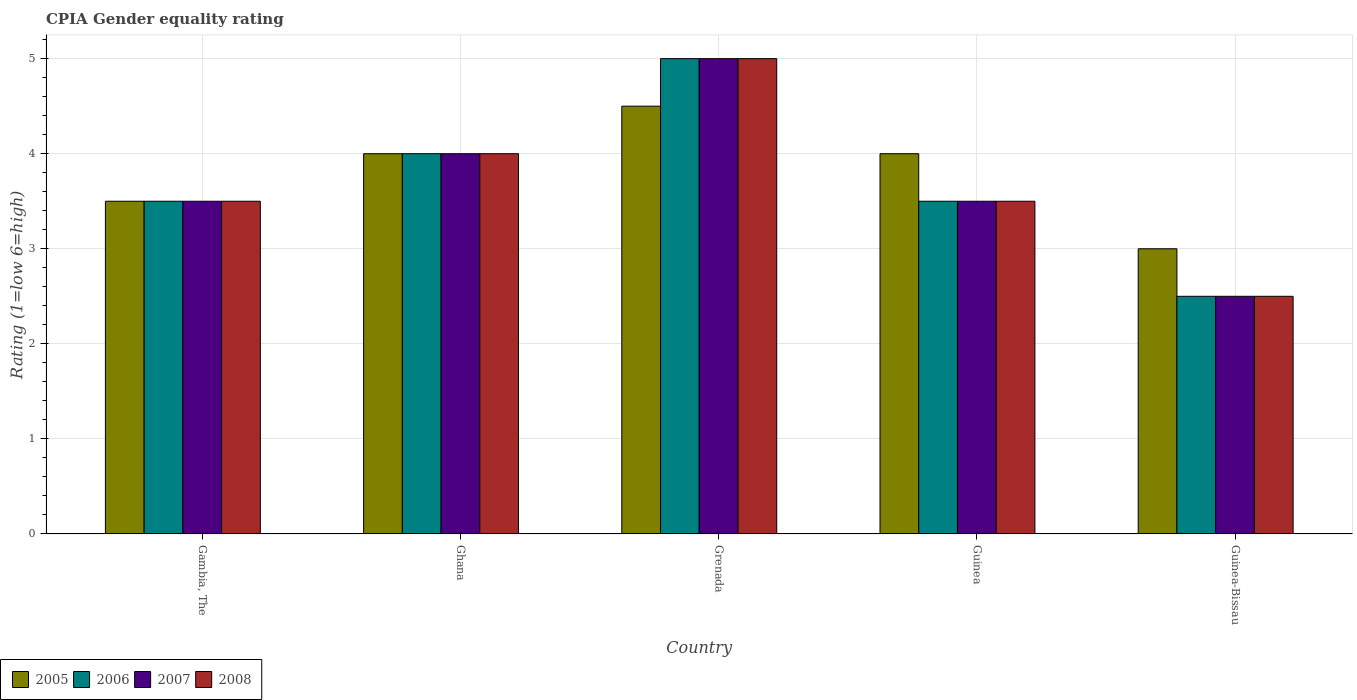How many different coloured bars are there?
Ensure brevity in your answer.  4. How many bars are there on the 5th tick from the right?
Ensure brevity in your answer.  4. What is the label of the 3rd group of bars from the left?
Offer a terse response. Grenada. In how many cases, is the number of bars for a given country not equal to the number of legend labels?
Give a very brief answer. 0. What is the CPIA rating in 2006 in Grenada?
Offer a very short reply. 5. Across all countries, what is the maximum CPIA rating in 2006?
Make the answer very short. 5. In which country was the CPIA rating in 2008 maximum?
Make the answer very short. Grenada. In which country was the CPIA rating in 2008 minimum?
Keep it short and to the point. Guinea-Bissau. What is the difference between the CPIA rating in 2006 in Grenada and the CPIA rating in 2005 in Gambia, The?
Offer a very short reply. 1.5. What is the average CPIA rating in 2005 per country?
Your answer should be very brief. 3.8. What is the ratio of the CPIA rating in 2005 in Ghana to that in Guinea?
Offer a very short reply. 1. Is the CPIA rating in 2006 in Gambia, The less than that in Ghana?
Ensure brevity in your answer.  Yes. Is the difference between the CPIA rating in 2006 in Gambia, The and Ghana greater than the difference between the CPIA rating in 2007 in Gambia, The and Ghana?
Offer a very short reply. No. What is the difference between the highest and the lowest CPIA rating in 2005?
Provide a succinct answer. 1.5. Is the sum of the CPIA rating in 2006 in Ghana and Guinea greater than the maximum CPIA rating in 2008 across all countries?
Offer a very short reply. Yes. Is it the case that in every country, the sum of the CPIA rating in 2008 and CPIA rating in 2006 is greater than the sum of CPIA rating in 2005 and CPIA rating in 2007?
Your answer should be compact. No. What does the 3rd bar from the left in Grenada represents?
Offer a terse response. 2007. What does the 4th bar from the right in Grenada represents?
Provide a short and direct response. 2005. Is it the case that in every country, the sum of the CPIA rating in 2008 and CPIA rating in 2006 is greater than the CPIA rating in 2005?
Make the answer very short. Yes. Are all the bars in the graph horizontal?
Ensure brevity in your answer.  No. Does the graph contain any zero values?
Ensure brevity in your answer.  No. Does the graph contain grids?
Make the answer very short. Yes. How many legend labels are there?
Keep it short and to the point. 4. How are the legend labels stacked?
Offer a very short reply. Horizontal. What is the title of the graph?
Your answer should be compact. CPIA Gender equality rating. Does "2002" appear as one of the legend labels in the graph?
Provide a succinct answer. No. What is the label or title of the X-axis?
Ensure brevity in your answer.  Country. What is the Rating (1=low 6=high) in 2005 in Gambia, The?
Your answer should be very brief. 3.5. What is the Rating (1=low 6=high) in 2007 in Ghana?
Your response must be concise. 4. What is the Rating (1=low 6=high) of 2007 in Grenada?
Provide a short and direct response. 5. What is the Rating (1=low 6=high) of 2008 in Grenada?
Give a very brief answer. 5. What is the Rating (1=low 6=high) in 2006 in Guinea?
Provide a succinct answer. 3.5. What is the Rating (1=low 6=high) of 2006 in Guinea-Bissau?
Provide a succinct answer. 2.5. Across all countries, what is the maximum Rating (1=low 6=high) of 2007?
Make the answer very short. 5. Across all countries, what is the maximum Rating (1=low 6=high) in 2008?
Your response must be concise. 5. Across all countries, what is the minimum Rating (1=low 6=high) in 2007?
Give a very brief answer. 2.5. What is the total Rating (1=low 6=high) in 2005 in the graph?
Provide a short and direct response. 19. What is the difference between the Rating (1=low 6=high) in 2007 in Gambia, The and that in Ghana?
Your answer should be very brief. -0.5. What is the difference between the Rating (1=low 6=high) of 2008 in Gambia, The and that in Ghana?
Provide a succinct answer. -0.5. What is the difference between the Rating (1=low 6=high) of 2005 in Gambia, The and that in Grenada?
Make the answer very short. -1. What is the difference between the Rating (1=low 6=high) in 2006 in Gambia, The and that in Grenada?
Ensure brevity in your answer.  -1.5. What is the difference between the Rating (1=low 6=high) in 2007 in Gambia, The and that in Grenada?
Your response must be concise. -1.5. What is the difference between the Rating (1=low 6=high) in 2008 in Gambia, The and that in Grenada?
Offer a terse response. -1.5. What is the difference between the Rating (1=low 6=high) in 2005 in Gambia, The and that in Guinea?
Offer a very short reply. -0.5. What is the difference between the Rating (1=low 6=high) in 2006 in Gambia, The and that in Guinea?
Your response must be concise. 0. What is the difference between the Rating (1=low 6=high) of 2007 in Gambia, The and that in Guinea-Bissau?
Make the answer very short. 1. What is the difference between the Rating (1=low 6=high) in 2005 in Ghana and that in Guinea?
Provide a short and direct response. 0. What is the difference between the Rating (1=low 6=high) of 2006 in Ghana and that in Guinea?
Give a very brief answer. 0.5. What is the difference between the Rating (1=low 6=high) of 2008 in Ghana and that in Guinea?
Provide a short and direct response. 0.5. What is the difference between the Rating (1=low 6=high) in 2005 in Ghana and that in Guinea-Bissau?
Offer a very short reply. 1. What is the difference between the Rating (1=low 6=high) of 2007 in Ghana and that in Guinea-Bissau?
Provide a succinct answer. 1.5. What is the difference between the Rating (1=low 6=high) in 2005 in Grenada and that in Guinea?
Make the answer very short. 0.5. What is the difference between the Rating (1=low 6=high) in 2006 in Grenada and that in Guinea?
Offer a terse response. 1.5. What is the difference between the Rating (1=low 6=high) of 2008 in Grenada and that in Guinea?
Ensure brevity in your answer.  1.5. What is the difference between the Rating (1=low 6=high) of 2005 in Grenada and that in Guinea-Bissau?
Give a very brief answer. 1.5. What is the difference between the Rating (1=low 6=high) of 2007 in Grenada and that in Guinea-Bissau?
Offer a very short reply. 2.5. What is the difference between the Rating (1=low 6=high) in 2005 in Guinea and that in Guinea-Bissau?
Provide a short and direct response. 1. What is the difference between the Rating (1=low 6=high) of 2006 in Guinea and that in Guinea-Bissau?
Your answer should be very brief. 1. What is the difference between the Rating (1=low 6=high) of 2007 in Guinea and that in Guinea-Bissau?
Your answer should be very brief. 1. What is the difference between the Rating (1=low 6=high) in 2007 in Gambia, The and the Rating (1=low 6=high) in 2008 in Ghana?
Make the answer very short. -0.5. What is the difference between the Rating (1=low 6=high) in 2006 in Gambia, The and the Rating (1=low 6=high) in 2008 in Grenada?
Your response must be concise. -1.5. What is the difference between the Rating (1=low 6=high) of 2007 in Gambia, The and the Rating (1=low 6=high) of 2008 in Grenada?
Your answer should be very brief. -1.5. What is the difference between the Rating (1=low 6=high) of 2005 in Gambia, The and the Rating (1=low 6=high) of 2006 in Guinea?
Your answer should be very brief. 0. What is the difference between the Rating (1=low 6=high) in 2005 in Gambia, The and the Rating (1=low 6=high) in 2008 in Guinea?
Offer a very short reply. 0. What is the difference between the Rating (1=low 6=high) of 2005 in Gambia, The and the Rating (1=low 6=high) of 2006 in Guinea-Bissau?
Ensure brevity in your answer.  1. What is the difference between the Rating (1=low 6=high) in 2005 in Gambia, The and the Rating (1=low 6=high) in 2008 in Guinea-Bissau?
Provide a succinct answer. 1. What is the difference between the Rating (1=low 6=high) in 2006 in Gambia, The and the Rating (1=low 6=high) in 2007 in Guinea-Bissau?
Provide a short and direct response. 1. What is the difference between the Rating (1=low 6=high) in 2006 in Gambia, The and the Rating (1=low 6=high) in 2008 in Guinea-Bissau?
Offer a very short reply. 1. What is the difference between the Rating (1=low 6=high) in 2005 in Ghana and the Rating (1=low 6=high) in 2007 in Grenada?
Make the answer very short. -1. What is the difference between the Rating (1=low 6=high) of 2005 in Ghana and the Rating (1=low 6=high) of 2008 in Grenada?
Provide a short and direct response. -1. What is the difference between the Rating (1=low 6=high) in 2005 in Ghana and the Rating (1=low 6=high) in 2006 in Guinea?
Offer a very short reply. 0.5. What is the difference between the Rating (1=low 6=high) of 2005 in Ghana and the Rating (1=low 6=high) of 2007 in Guinea?
Provide a short and direct response. 0.5. What is the difference between the Rating (1=low 6=high) in 2006 in Ghana and the Rating (1=low 6=high) in 2007 in Guinea?
Offer a very short reply. 0.5. What is the difference between the Rating (1=low 6=high) in 2005 in Ghana and the Rating (1=low 6=high) in 2007 in Guinea-Bissau?
Provide a short and direct response. 1.5. What is the difference between the Rating (1=low 6=high) of 2005 in Ghana and the Rating (1=low 6=high) of 2008 in Guinea-Bissau?
Give a very brief answer. 1.5. What is the difference between the Rating (1=low 6=high) in 2006 in Ghana and the Rating (1=low 6=high) in 2007 in Guinea-Bissau?
Your response must be concise. 1.5. What is the difference between the Rating (1=low 6=high) in 2005 in Grenada and the Rating (1=low 6=high) in 2007 in Guinea?
Give a very brief answer. 1. What is the difference between the Rating (1=low 6=high) in 2006 in Grenada and the Rating (1=low 6=high) in 2008 in Guinea?
Give a very brief answer. 1.5. What is the difference between the Rating (1=low 6=high) in 2005 in Grenada and the Rating (1=low 6=high) in 2008 in Guinea-Bissau?
Make the answer very short. 2. What is the difference between the Rating (1=low 6=high) in 2006 in Grenada and the Rating (1=low 6=high) in 2007 in Guinea-Bissau?
Keep it short and to the point. 2.5. What is the difference between the Rating (1=low 6=high) in 2006 in Grenada and the Rating (1=low 6=high) in 2008 in Guinea-Bissau?
Provide a short and direct response. 2.5. What is the difference between the Rating (1=low 6=high) of 2005 in Guinea and the Rating (1=low 6=high) of 2006 in Guinea-Bissau?
Your response must be concise. 1.5. What is the difference between the Rating (1=low 6=high) in 2006 in Guinea and the Rating (1=low 6=high) in 2008 in Guinea-Bissau?
Offer a very short reply. 1. What is the average Rating (1=low 6=high) of 2005 per country?
Make the answer very short. 3.8. What is the difference between the Rating (1=low 6=high) of 2005 and Rating (1=low 6=high) of 2006 in Gambia, The?
Your answer should be compact. 0. What is the difference between the Rating (1=low 6=high) of 2006 and Rating (1=low 6=high) of 2008 in Gambia, The?
Offer a terse response. 0. What is the difference between the Rating (1=low 6=high) in 2005 and Rating (1=low 6=high) in 2006 in Ghana?
Your answer should be very brief. 0. What is the difference between the Rating (1=low 6=high) of 2005 and Rating (1=low 6=high) of 2008 in Ghana?
Provide a succinct answer. 0. What is the difference between the Rating (1=low 6=high) of 2006 and Rating (1=low 6=high) of 2007 in Ghana?
Your answer should be very brief. 0. What is the difference between the Rating (1=low 6=high) of 2007 and Rating (1=low 6=high) of 2008 in Ghana?
Give a very brief answer. 0. What is the difference between the Rating (1=low 6=high) in 2005 and Rating (1=low 6=high) in 2006 in Grenada?
Ensure brevity in your answer.  -0.5. What is the difference between the Rating (1=low 6=high) of 2005 and Rating (1=low 6=high) of 2007 in Grenada?
Offer a very short reply. -0.5. What is the difference between the Rating (1=low 6=high) of 2005 and Rating (1=low 6=high) of 2008 in Grenada?
Your answer should be very brief. -0.5. What is the difference between the Rating (1=low 6=high) of 2006 and Rating (1=low 6=high) of 2007 in Grenada?
Make the answer very short. 0. What is the difference between the Rating (1=low 6=high) in 2006 and Rating (1=low 6=high) in 2008 in Grenada?
Give a very brief answer. 0. What is the difference between the Rating (1=low 6=high) of 2007 and Rating (1=low 6=high) of 2008 in Grenada?
Make the answer very short. 0. What is the difference between the Rating (1=low 6=high) of 2005 and Rating (1=low 6=high) of 2007 in Guinea?
Offer a terse response. 0.5. What is the difference between the Rating (1=low 6=high) in 2005 and Rating (1=low 6=high) in 2007 in Guinea-Bissau?
Provide a succinct answer. 0.5. What is the difference between the Rating (1=low 6=high) of 2006 and Rating (1=low 6=high) of 2008 in Guinea-Bissau?
Give a very brief answer. 0. What is the ratio of the Rating (1=low 6=high) of 2006 in Gambia, The to that in Ghana?
Your answer should be very brief. 0.88. What is the ratio of the Rating (1=low 6=high) of 2005 in Gambia, The to that in Grenada?
Your response must be concise. 0.78. What is the ratio of the Rating (1=low 6=high) in 2008 in Gambia, The to that in Grenada?
Provide a short and direct response. 0.7. What is the ratio of the Rating (1=low 6=high) in 2005 in Gambia, The to that in Guinea?
Your answer should be compact. 0.88. What is the ratio of the Rating (1=low 6=high) in 2008 in Gambia, The to that in Guinea-Bissau?
Provide a short and direct response. 1.4. What is the ratio of the Rating (1=low 6=high) in 2005 in Ghana to that in Grenada?
Keep it short and to the point. 0.89. What is the ratio of the Rating (1=low 6=high) of 2008 in Ghana to that in Grenada?
Give a very brief answer. 0.8. What is the ratio of the Rating (1=low 6=high) of 2005 in Ghana to that in Guinea?
Offer a terse response. 1. What is the ratio of the Rating (1=low 6=high) in 2007 in Ghana to that in Guinea?
Provide a short and direct response. 1.14. What is the ratio of the Rating (1=low 6=high) in 2005 in Ghana to that in Guinea-Bissau?
Your response must be concise. 1.33. What is the ratio of the Rating (1=low 6=high) in 2006 in Ghana to that in Guinea-Bissau?
Offer a very short reply. 1.6. What is the ratio of the Rating (1=low 6=high) of 2006 in Grenada to that in Guinea?
Offer a terse response. 1.43. What is the ratio of the Rating (1=low 6=high) in 2007 in Grenada to that in Guinea?
Your response must be concise. 1.43. What is the ratio of the Rating (1=low 6=high) in 2008 in Grenada to that in Guinea?
Provide a succinct answer. 1.43. What is the ratio of the Rating (1=low 6=high) of 2006 in Grenada to that in Guinea-Bissau?
Make the answer very short. 2. What is the ratio of the Rating (1=low 6=high) of 2007 in Grenada to that in Guinea-Bissau?
Your answer should be very brief. 2. What is the ratio of the Rating (1=low 6=high) in 2008 in Grenada to that in Guinea-Bissau?
Make the answer very short. 2. What is the ratio of the Rating (1=low 6=high) of 2005 in Guinea to that in Guinea-Bissau?
Give a very brief answer. 1.33. What is the ratio of the Rating (1=low 6=high) of 2007 in Guinea to that in Guinea-Bissau?
Give a very brief answer. 1.4. What is the ratio of the Rating (1=low 6=high) of 2008 in Guinea to that in Guinea-Bissau?
Offer a very short reply. 1.4. What is the difference between the highest and the second highest Rating (1=low 6=high) in 2008?
Provide a short and direct response. 1. What is the difference between the highest and the lowest Rating (1=low 6=high) of 2005?
Keep it short and to the point. 1.5. 